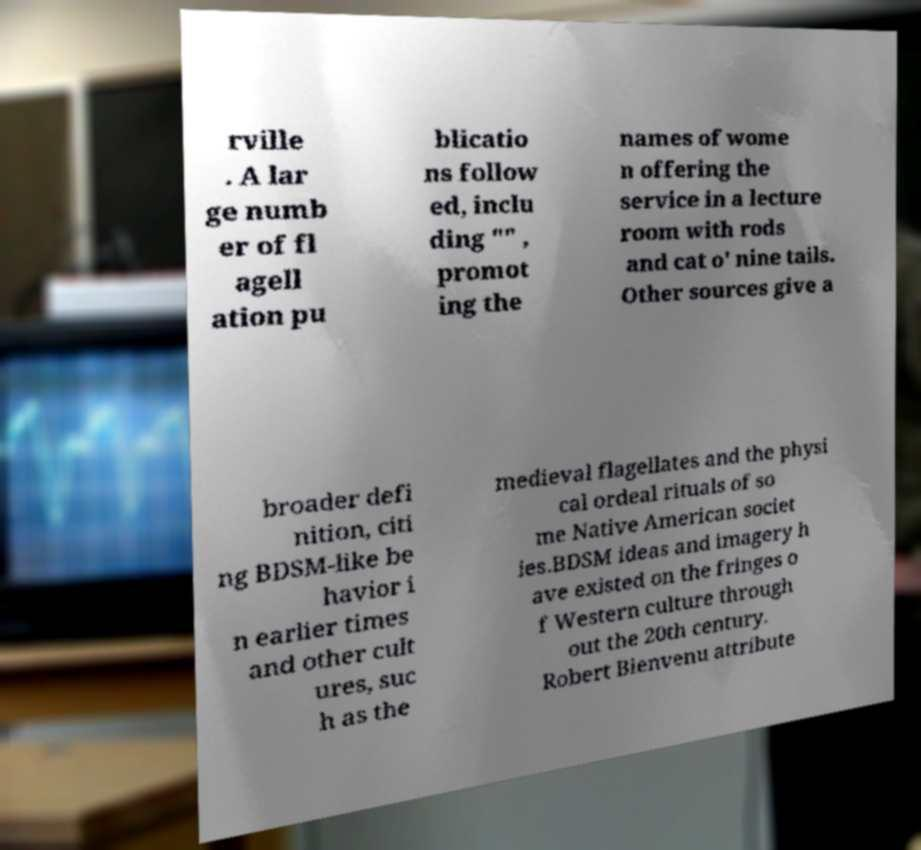Could you assist in decoding the text presented in this image and type it out clearly? rville . A lar ge numb er of fl agell ation pu blicatio ns follow ed, inclu ding "" , promot ing the names of wome n offering the service in a lecture room with rods and cat o' nine tails. Other sources give a broader defi nition, citi ng BDSM-like be havior i n earlier times and other cult ures, suc h as the medieval flagellates and the physi cal ordeal rituals of so me Native American societ ies.BDSM ideas and imagery h ave existed on the fringes o f Western culture through out the 20th century. Robert Bienvenu attribute 